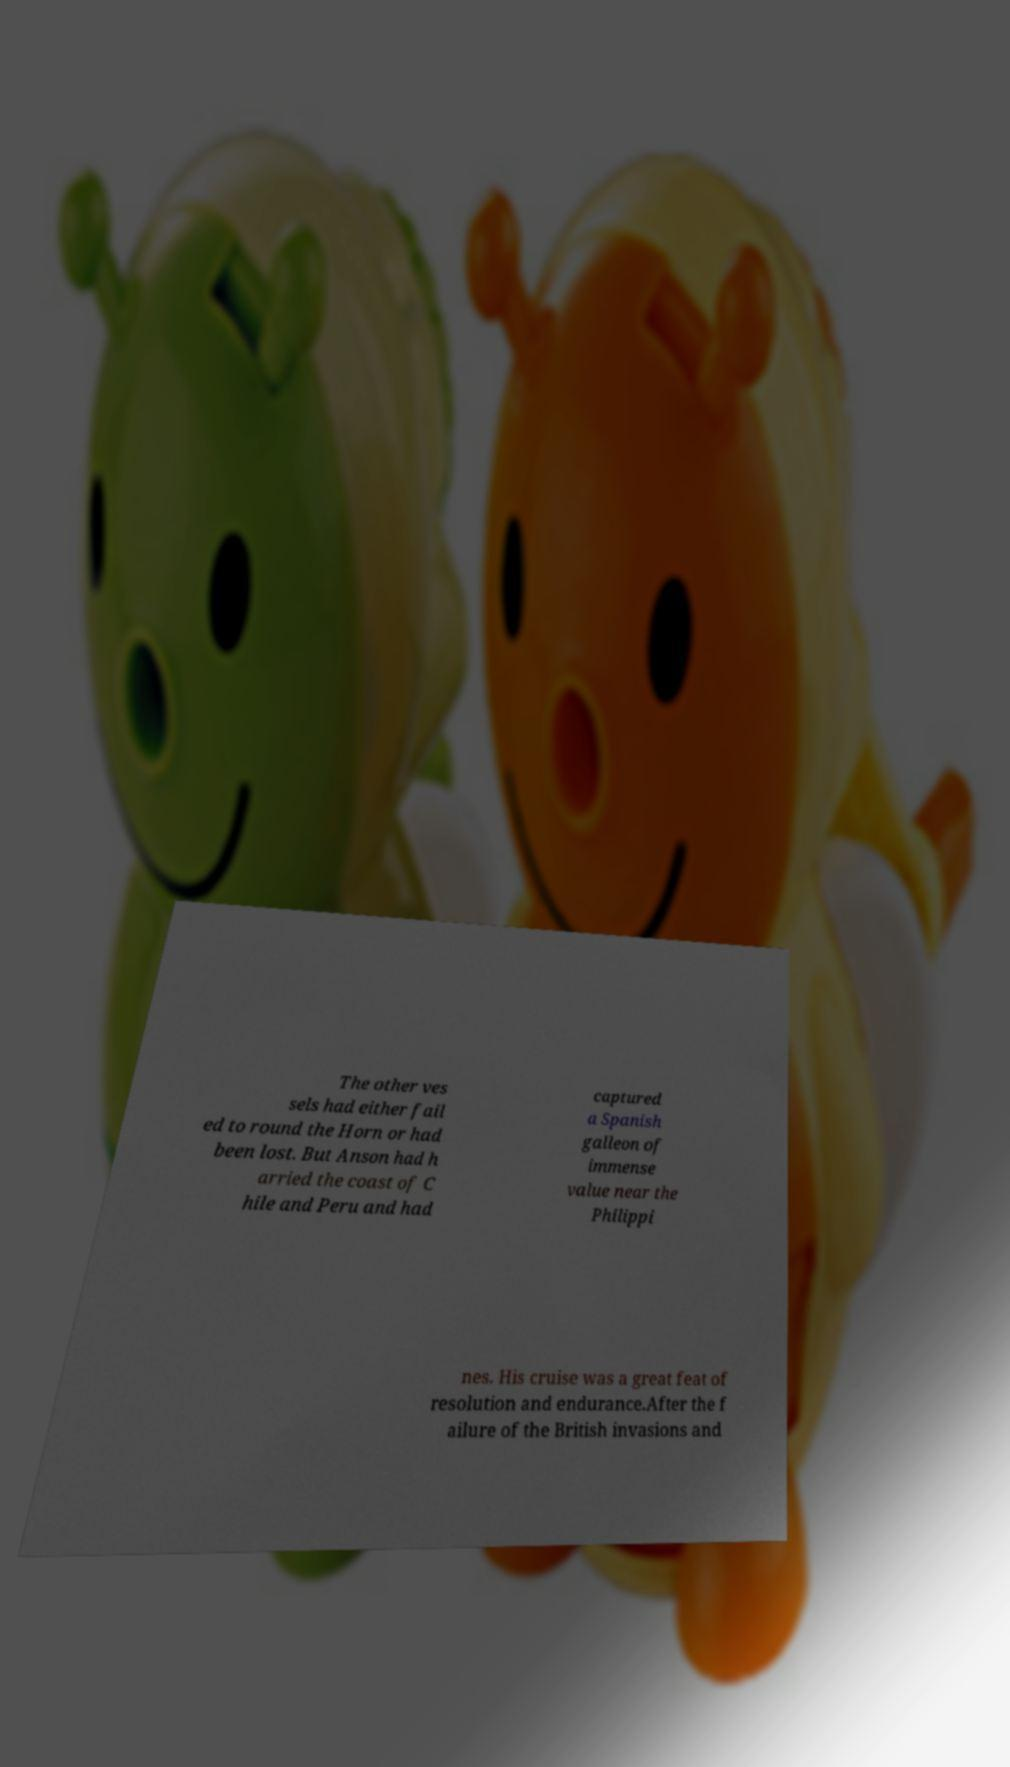I need the written content from this picture converted into text. Can you do that? The other ves sels had either fail ed to round the Horn or had been lost. But Anson had h arried the coast of C hile and Peru and had captured a Spanish galleon of immense value near the Philippi nes. His cruise was a great feat of resolution and endurance.After the f ailure of the British invasions and 